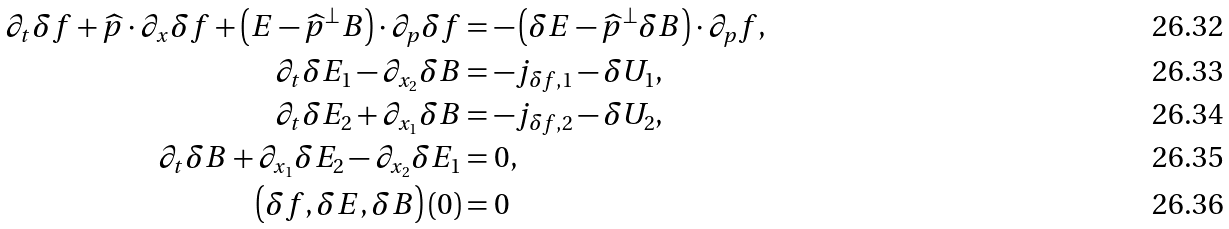Convert formula to latex. <formula><loc_0><loc_0><loc_500><loc_500>\partial _ { t } \delta f + \widehat { p } \cdot \partial _ { x } \delta f + \left ( E - \widehat { p } ^ { \bot } B \right ) \cdot \partial _ { p } \delta f & = - \left ( \delta E - \widehat { p } ^ { \bot } \delta B \right ) \cdot \partial _ { p } f , \\ \partial _ { t } \delta E _ { 1 } - \partial _ { x _ { 2 } } \delta B & = - j _ { \delta f , 1 } - \delta U _ { 1 } , \\ \partial _ { t } \delta E _ { 2 } + \partial _ { x _ { 1 } } \delta B & = - j _ { \delta f , 2 } - \delta U _ { 2 } , \\ \partial _ { t } \delta B + \partial _ { x _ { 1 } } \delta E _ { 2 } - \partial _ { x _ { 2 } } \delta E _ { 1 } & = 0 , \\ \left ( \delta f , \delta E , \delta B \right ) \left ( 0 \right ) & = 0</formula> 